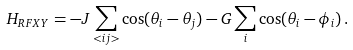Convert formula to latex. <formula><loc_0><loc_0><loc_500><loc_500>H _ { R F X Y } = - J \sum _ { < i j > } \cos ( \theta _ { i } - \theta _ { j } ) - G \sum _ { i } \cos ( \theta _ { i } - \phi _ { i } ) \, .</formula> 